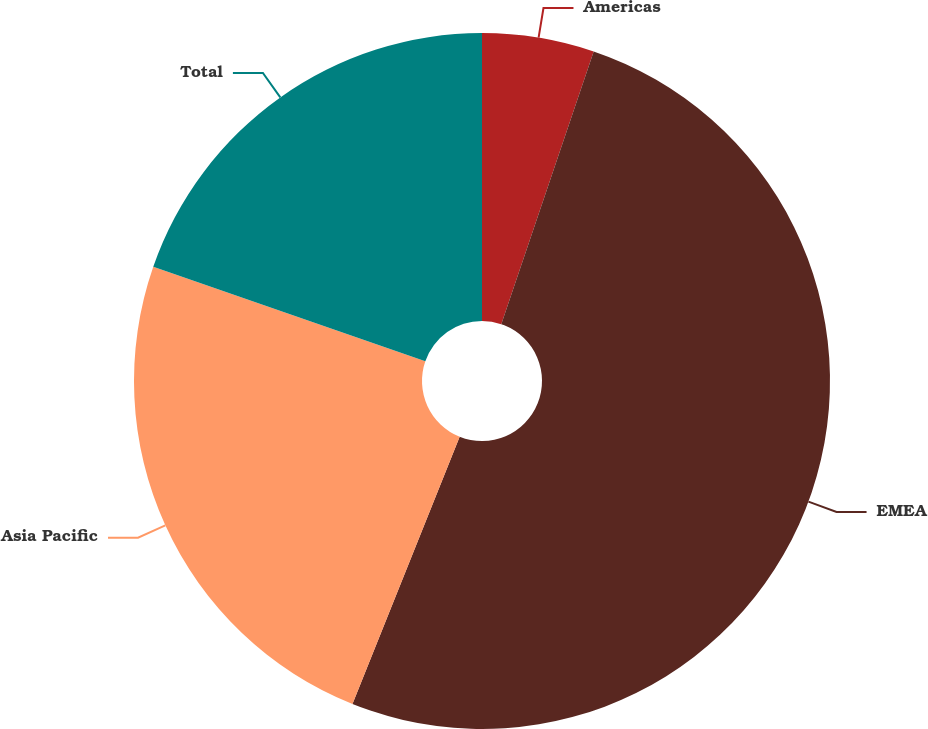Convert chart to OTSL. <chart><loc_0><loc_0><loc_500><loc_500><pie_chart><fcel>Americas<fcel>EMEA<fcel>Asia Pacific<fcel>Total<nl><fcel>5.2%<fcel>50.87%<fcel>24.25%<fcel>19.68%<nl></chart> 